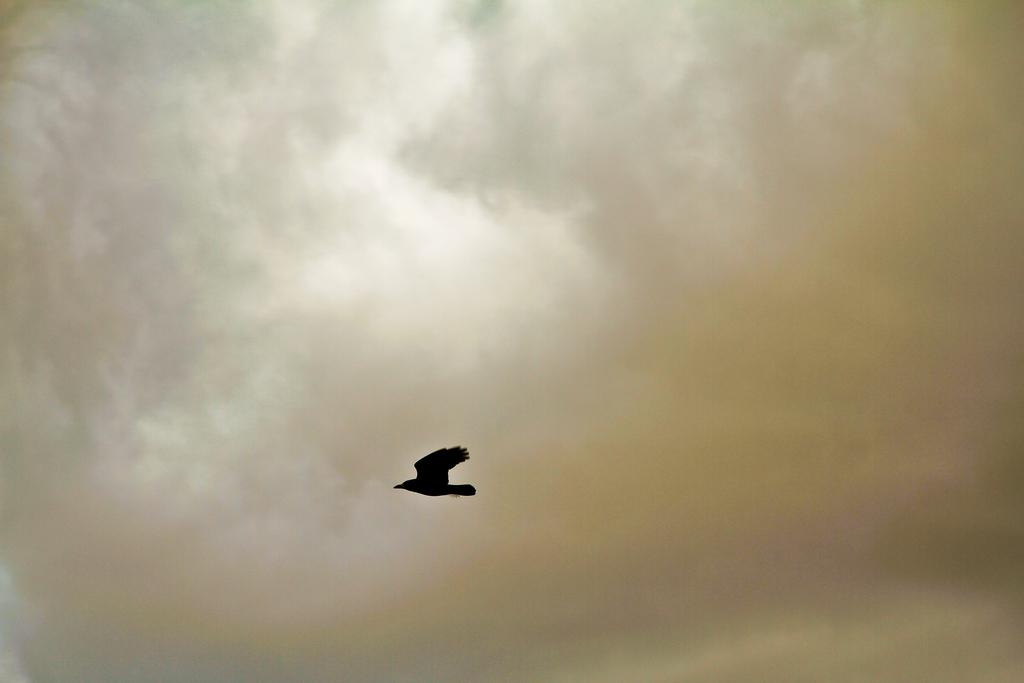What type of bird is in the image? There is a black crow in the image. What is the condition of the sky in the image? The sky in the image is cloudy. What type of fruit is the crow holding in its beak in the image? There is no fruit visible in the image, and the crow is not holding anything in its beak. What type of container is the crow carrying on its back in the image? There is no container visible on the crow's back in the image. 